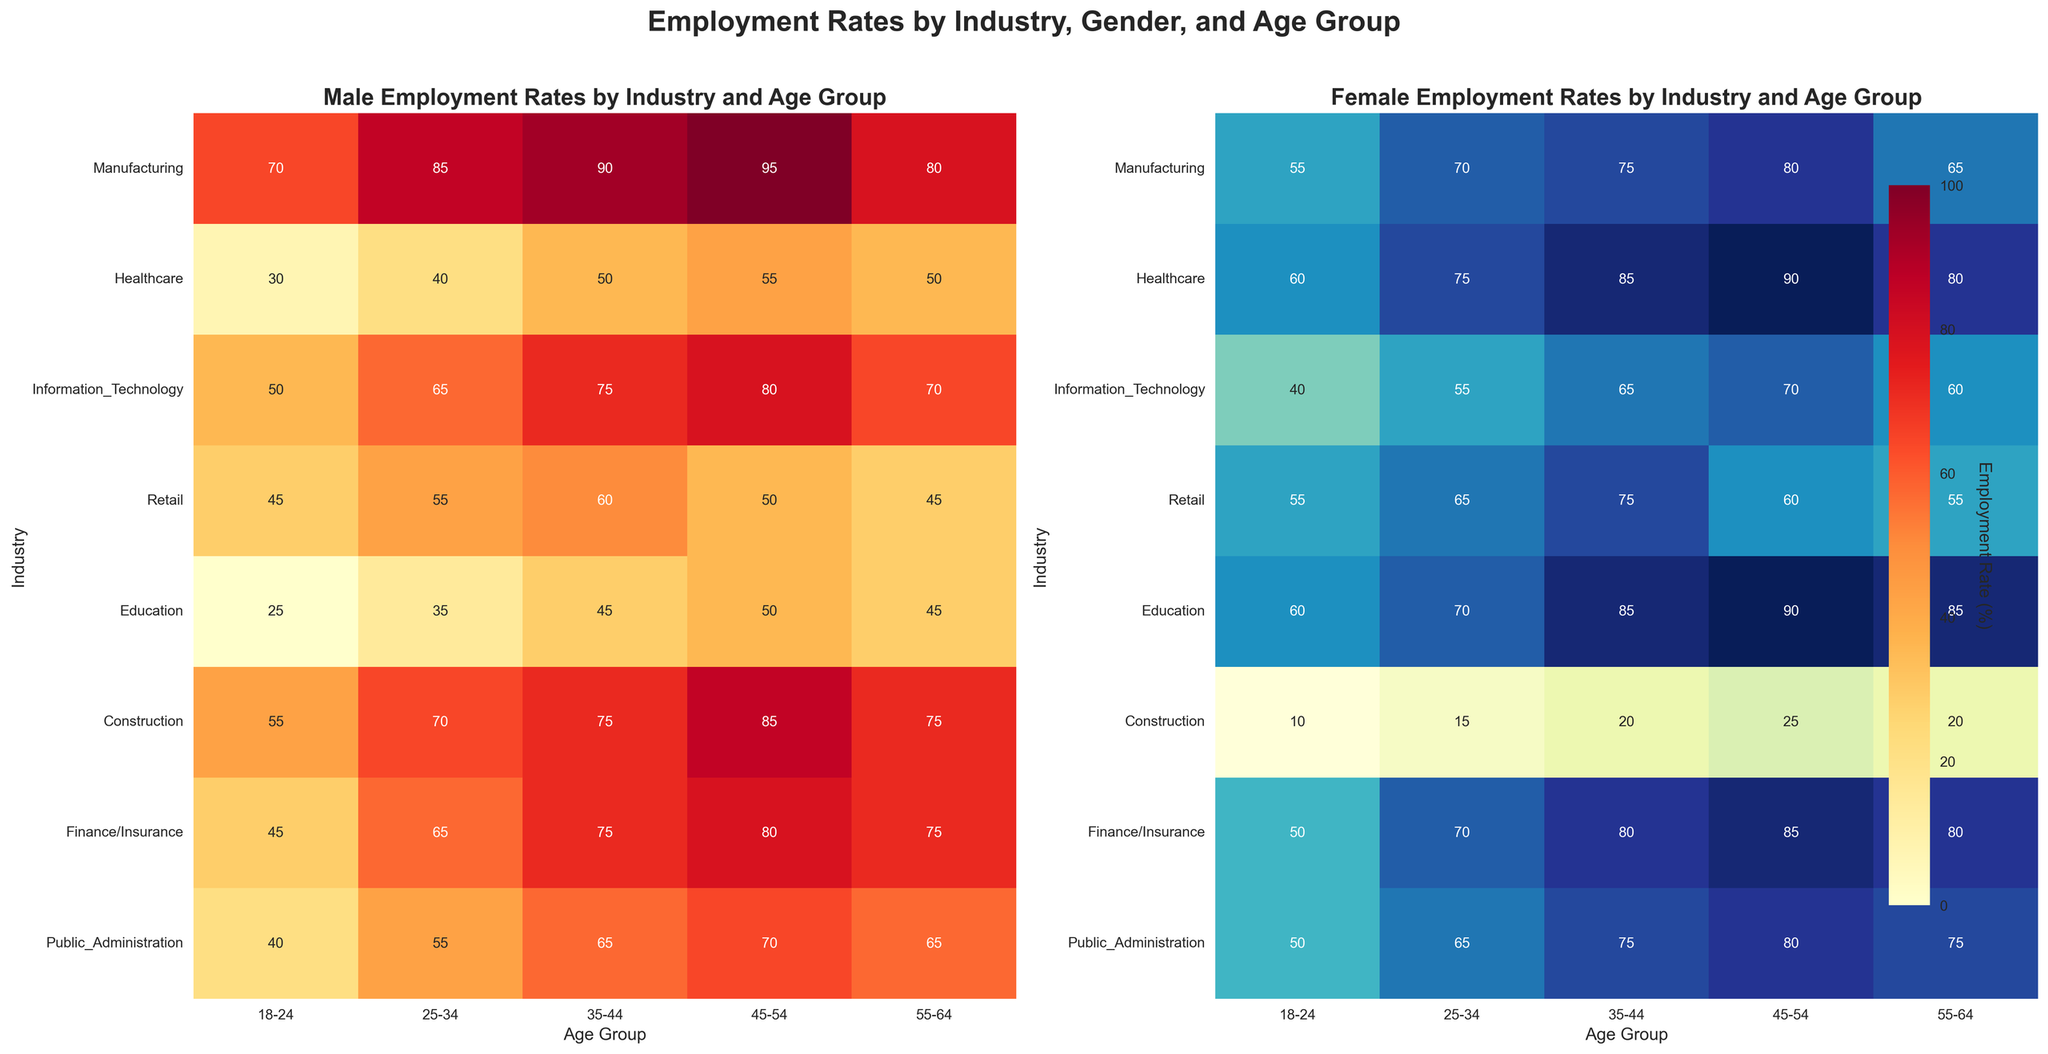What is the employment rate for females in the Manufacturing industry for the age group 35-44? Find the cell in the Female heatmap under Manufacturing row and 35-44 column. The number displayed is the employment rate.
Answer: 75 Which industry shows the largest employment rate difference between males and females in the age group 25-34? Find the difference in employment rates between males and females for each industry in the 25-34 age group and compare them. The industry with the largest difference will be the answer.
Answer: Manufacturing (15) In which age group do males in the Retail industry have the lowest employment rate? Locate the Retail row in the Male heatmap and identify the cell with the lowest number. The corresponding column label is the age group.
Answer: 55-64 How does the employment rate for females in the Healthcare industry change from ages 25-34 to 45-54? Find the values for the Healthcare row in the Female heatmap under 25-34 and 45-54 columns, then determine the difference or rate of change.
Answer: Increases from 75 to 90 In which industry do females have a higher employment rate than males across all age groups? Check each age group column in the heatmaps and compare the Female and Male values for each industry. Identify the industry where the Female values are consistently higher.
Answer: Education What trend can be observed in the employment rates of males in the Information Technology industry as age increases? Look at the row for Information Technology in the Male heatmap and observe the changes in employment rates across columns from left to right (younger to older age groups).
Answer: Steadily increases until age group 45-54, then slightly decreases Which age group has the highest average employment rate for females across all industries? Calculate the average employment rate for females in each age group by summing the values in each column and dividing by the number of industries, then compare these averages.
Answer: 45-54 Is there a noticeable gender disparity in employment rates in the Construction industry? Compare the employment rates for males and females across all age groups in the Construction row. Note the differences in each cell.
Answer: Yes, males have significantly higher employment rates in all age groups Which industry shows the most significant drop in employment rate for males from 45-54 to 55-64? Compare the values in the 45-54 and 55-64 columns for each industry in the Male heatmap, then identify the biggest drop.
Answer: Retail (15) What is the overall trend in employment rates for both genders in the Finance/Insurance industry? Look at the rows for Finance/Insurance in both Male and Female heatmaps and observe the trend in employment rates across all age groups.
Answer: Generally increases with age 